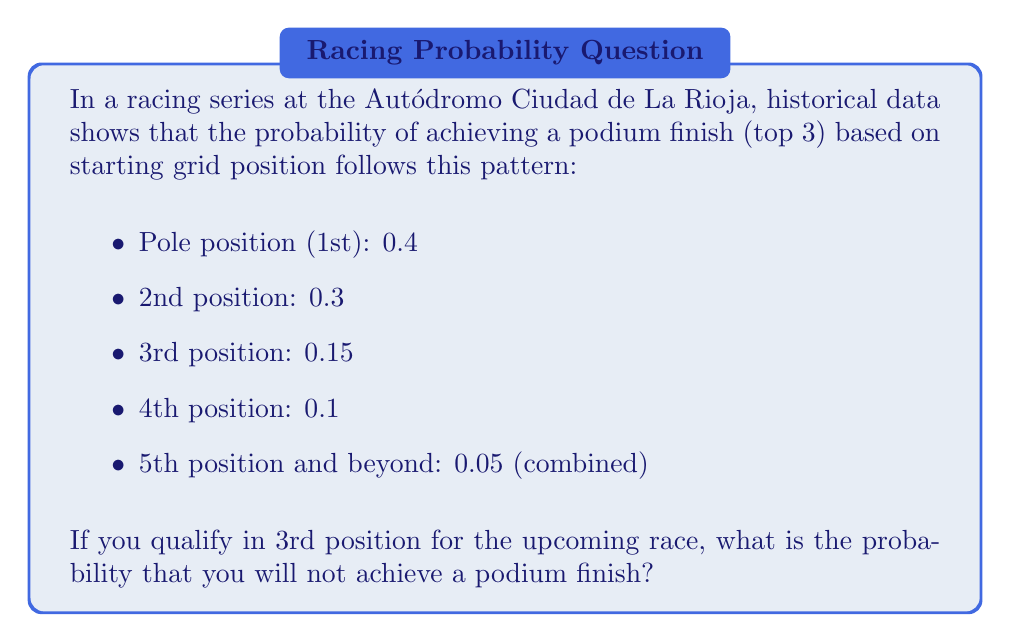Can you answer this question? To solve this problem, we need to use the concept of complementary events in probability theory. The probability of an event not occurring is equal to 1 minus the probability of it occurring.

Let's define our events:
A = achieving a podium finish
not A = not achieving a podium finish

We are given:
P(A | 3rd position) = 0.15

To find the probability of not achieving a podium finish, we use the complement rule:

P(not A) = 1 - P(A)

Substituting the given probability:

P(not A | 3rd position) = 1 - P(A | 3rd position)
                        = 1 - 0.15
                        = 0.85

Therefore, the probability of not achieving a podium finish when starting from 3rd position is 0.85 or 85%.
Answer: The probability of not achieving a podium finish when starting from 3rd position is 0.85 or 85%. 